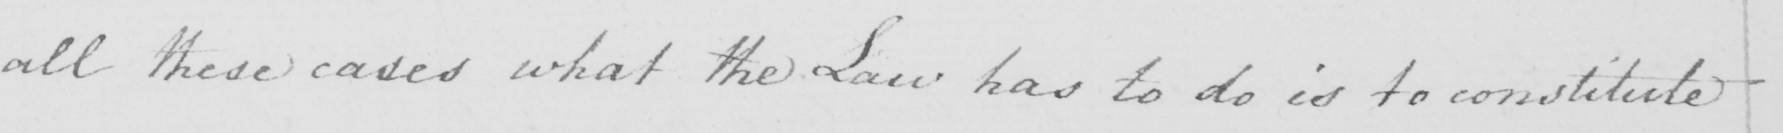What does this handwritten line say? all these cases what the Law has to do is to constitute 